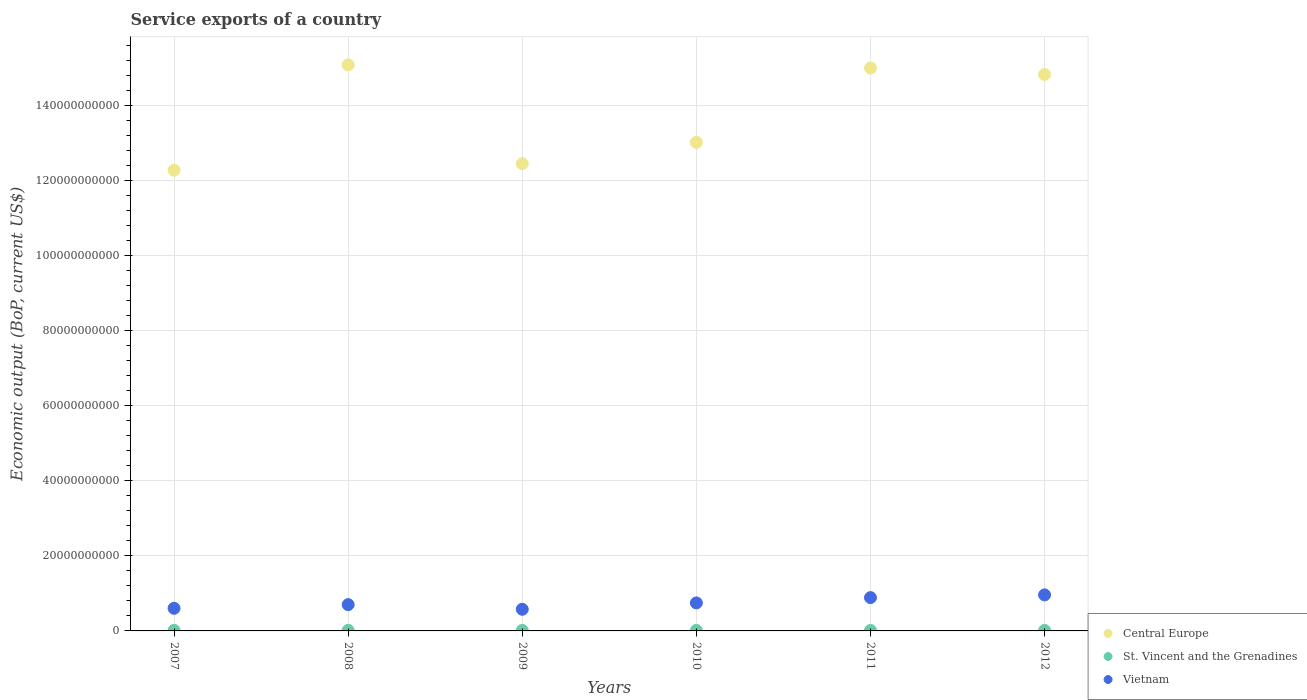How many different coloured dotlines are there?
Make the answer very short. 3. Is the number of dotlines equal to the number of legend labels?
Provide a short and direct response. Yes. What is the service exports in Central Europe in 2009?
Your answer should be compact. 1.25e+11. Across all years, what is the maximum service exports in St. Vincent and the Grenadines?
Make the answer very short. 1.61e+08. Across all years, what is the minimum service exports in Central Europe?
Provide a short and direct response. 1.23e+11. In which year was the service exports in Central Europe maximum?
Give a very brief answer. 2008. What is the total service exports in St. Vincent and the Grenadines in the graph?
Give a very brief answer. 8.71e+08. What is the difference between the service exports in St. Vincent and the Grenadines in 2007 and that in 2010?
Provide a short and direct response. 2.27e+07. What is the difference between the service exports in St. Vincent and the Grenadines in 2011 and the service exports in Vietnam in 2012?
Give a very brief answer. -9.46e+09. What is the average service exports in St. Vincent and the Grenadines per year?
Your answer should be very brief. 1.45e+08. In the year 2009, what is the difference between the service exports in St. Vincent and the Grenadines and service exports in Central Europe?
Your answer should be compact. -1.24e+11. What is the ratio of the service exports in Central Europe in 2008 to that in 2010?
Your answer should be compact. 1.16. Is the difference between the service exports in St. Vincent and the Grenadines in 2008 and 2009 greater than the difference between the service exports in Central Europe in 2008 and 2009?
Give a very brief answer. No. What is the difference between the highest and the second highest service exports in St. Vincent and the Grenadines?
Ensure brevity in your answer.  7.89e+06. What is the difference between the highest and the lowest service exports in Central Europe?
Your response must be concise. 2.81e+1. Is the sum of the service exports in St. Vincent and the Grenadines in 2009 and 2012 greater than the maximum service exports in Vietnam across all years?
Ensure brevity in your answer.  No. Is it the case that in every year, the sum of the service exports in Vietnam and service exports in St. Vincent and the Grenadines  is greater than the service exports in Central Europe?
Offer a very short reply. No. Is the service exports in Central Europe strictly greater than the service exports in Vietnam over the years?
Give a very brief answer. Yes. Are the values on the major ticks of Y-axis written in scientific E-notation?
Give a very brief answer. No. How many legend labels are there?
Ensure brevity in your answer.  3. How are the legend labels stacked?
Your response must be concise. Vertical. What is the title of the graph?
Provide a short and direct response. Service exports of a country. Does "Morocco" appear as one of the legend labels in the graph?
Your response must be concise. No. What is the label or title of the X-axis?
Make the answer very short. Years. What is the label or title of the Y-axis?
Keep it short and to the point. Economic output (BoP, current US$). What is the Economic output (BoP, current US$) in Central Europe in 2007?
Your answer should be compact. 1.23e+11. What is the Economic output (BoP, current US$) of St. Vincent and the Grenadines in 2007?
Your response must be concise. 1.61e+08. What is the Economic output (BoP, current US$) of Vietnam in 2007?
Ensure brevity in your answer.  6.03e+09. What is the Economic output (BoP, current US$) in Central Europe in 2008?
Your answer should be compact. 1.51e+11. What is the Economic output (BoP, current US$) in St. Vincent and the Grenadines in 2008?
Make the answer very short. 1.53e+08. What is the Economic output (BoP, current US$) of Vietnam in 2008?
Offer a terse response. 7.01e+09. What is the Economic output (BoP, current US$) in Central Europe in 2009?
Offer a very short reply. 1.25e+11. What is the Economic output (BoP, current US$) of St. Vincent and the Grenadines in 2009?
Offer a very short reply. 1.39e+08. What is the Economic output (BoP, current US$) in Vietnam in 2009?
Offer a very short reply. 5.77e+09. What is the Economic output (BoP, current US$) in Central Europe in 2010?
Give a very brief answer. 1.30e+11. What is the Economic output (BoP, current US$) of St. Vincent and the Grenadines in 2010?
Provide a succinct answer. 1.38e+08. What is the Economic output (BoP, current US$) in Vietnam in 2010?
Give a very brief answer. 7.46e+09. What is the Economic output (BoP, current US$) in Central Europe in 2011?
Your answer should be compact. 1.50e+11. What is the Economic output (BoP, current US$) in St. Vincent and the Grenadines in 2011?
Provide a succinct answer. 1.39e+08. What is the Economic output (BoP, current US$) of Vietnam in 2011?
Your response must be concise. 8.88e+09. What is the Economic output (BoP, current US$) in Central Europe in 2012?
Keep it short and to the point. 1.48e+11. What is the Economic output (BoP, current US$) in St. Vincent and the Grenadines in 2012?
Make the answer very short. 1.40e+08. What is the Economic output (BoP, current US$) in Vietnam in 2012?
Provide a short and direct response. 9.60e+09. Across all years, what is the maximum Economic output (BoP, current US$) in Central Europe?
Give a very brief answer. 1.51e+11. Across all years, what is the maximum Economic output (BoP, current US$) in St. Vincent and the Grenadines?
Your answer should be very brief. 1.61e+08. Across all years, what is the maximum Economic output (BoP, current US$) in Vietnam?
Ensure brevity in your answer.  9.60e+09. Across all years, what is the minimum Economic output (BoP, current US$) in Central Europe?
Ensure brevity in your answer.  1.23e+11. Across all years, what is the minimum Economic output (BoP, current US$) in St. Vincent and the Grenadines?
Make the answer very short. 1.38e+08. Across all years, what is the minimum Economic output (BoP, current US$) of Vietnam?
Keep it short and to the point. 5.77e+09. What is the total Economic output (BoP, current US$) in Central Europe in the graph?
Give a very brief answer. 8.27e+11. What is the total Economic output (BoP, current US$) in St. Vincent and the Grenadines in the graph?
Make the answer very short. 8.71e+08. What is the total Economic output (BoP, current US$) of Vietnam in the graph?
Provide a short and direct response. 4.47e+1. What is the difference between the Economic output (BoP, current US$) of Central Europe in 2007 and that in 2008?
Your response must be concise. -2.81e+1. What is the difference between the Economic output (BoP, current US$) in St. Vincent and the Grenadines in 2007 and that in 2008?
Give a very brief answer. 7.89e+06. What is the difference between the Economic output (BoP, current US$) in Vietnam in 2007 and that in 2008?
Your response must be concise. -9.76e+08. What is the difference between the Economic output (BoP, current US$) in Central Europe in 2007 and that in 2009?
Ensure brevity in your answer.  -1.76e+09. What is the difference between the Economic output (BoP, current US$) in St. Vincent and the Grenadines in 2007 and that in 2009?
Offer a terse response. 2.19e+07. What is the difference between the Economic output (BoP, current US$) in Vietnam in 2007 and that in 2009?
Ensure brevity in your answer.  2.64e+08. What is the difference between the Economic output (BoP, current US$) in Central Europe in 2007 and that in 2010?
Offer a terse response. -7.44e+09. What is the difference between the Economic output (BoP, current US$) of St. Vincent and the Grenadines in 2007 and that in 2010?
Provide a short and direct response. 2.27e+07. What is the difference between the Economic output (BoP, current US$) of Vietnam in 2007 and that in 2010?
Make the answer very short. -1.43e+09. What is the difference between the Economic output (BoP, current US$) in Central Europe in 2007 and that in 2011?
Your response must be concise. -2.72e+1. What is the difference between the Economic output (BoP, current US$) in St. Vincent and the Grenadines in 2007 and that in 2011?
Give a very brief answer. 2.15e+07. What is the difference between the Economic output (BoP, current US$) in Vietnam in 2007 and that in 2011?
Offer a terse response. -2.85e+09. What is the difference between the Economic output (BoP, current US$) in Central Europe in 2007 and that in 2012?
Offer a terse response. -2.55e+1. What is the difference between the Economic output (BoP, current US$) of St. Vincent and the Grenadines in 2007 and that in 2012?
Make the answer very short. 2.04e+07. What is the difference between the Economic output (BoP, current US$) of Vietnam in 2007 and that in 2012?
Provide a short and direct response. -3.57e+09. What is the difference between the Economic output (BoP, current US$) of Central Europe in 2008 and that in 2009?
Offer a very short reply. 2.63e+1. What is the difference between the Economic output (BoP, current US$) in St. Vincent and the Grenadines in 2008 and that in 2009?
Offer a terse response. 1.40e+07. What is the difference between the Economic output (BoP, current US$) of Vietnam in 2008 and that in 2009?
Provide a succinct answer. 1.24e+09. What is the difference between the Economic output (BoP, current US$) in Central Europe in 2008 and that in 2010?
Offer a very short reply. 2.06e+1. What is the difference between the Economic output (BoP, current US$) in St. Vincent and the Grenadines in 2008 and that in 2010?
Your answer should be compact. 1.48e+07. What is the difference between the Economic output (BoP, current US$) in Vietnam in 2008 and that in 2010?
Offer a very short reply. -4.54e+08. What is the difference between the Economic output (BoP, current US$) in Central Europe in 2008 and that in 2011?
Provide a short and direct response. 8.36e+08. What is the difference between the Economic output (BoP, current US$) in St. Vincent and the Grenadines in 2008 and that in 2011?
Offer a very short reply. 1.36e+07. What is the difference between the Economic output (BoP, current US$) of Vietnam in 2008 and that in 2011?
Give a very brief answer. -1.87e+09. What is the difference between the Economic output (BoP, current US$) in Central Europe in 2008 and that in 2012?
Your answer should be very brief. 2.55e+09. What is the difference between the Economic output (BoP, current US$) of St. Vincent and the Grenadines in 2008 and that in 2012?
Your answer should be compact. 1.25e+07. What is the difference between the Economic output (BoP, current US$) of Vietnam in 2008 and that in 2012?
Keep it short and to the point. -2.59e+09. What is the difference between the Economic output (BoP, current US$) of Central Europe in 2009 and that in 2010?
Keep it short and to the point. -5.67e+09. What is the difference between the Economic output (BoP, current US$) of St. Vincent and the Grenadines in 2009 and that in 2010?
Provide a succinct answer. 7.68e+05. What is the difference between the Economic output (BoP, current US$) in Vietnam in 2009 and that in 2010?
Make the answer very short. -1.69e+09. What is the difference between the Economic output (BoP, current US$) in Central Europe in 2009 and that in 2011?
Your answer should be very brief. -2.55e+1. What is the difference between the Economic output (BoP, current US$) in St. Vincent and the Grenadines in 2009 and that in 2011?
Make the answer very short. -4.17e+05. What is the difference between the Economic output (BoP, current US$) of Vietnam in 2009 and that in 2011?
Make the answer very short. -3.11e+09. What is the difference between the Economic output (BoP, current US$) in Central Europe in 2009 and that in 2012?
Your response must be concise. -2.38e+1. What is the difference between the Economic output (BoP, current US$) in St. Vincent and the Grenadines in 2009 and that in 2012?
Offer a terse response. -1.53e+06. What is the difference between the Economic output (BoP, current US$) of Vietnam in 2009 and that in 2012?
Keep it short and to the point. -3.83e+09. What is the difference between the Economic output (BoP, current US$) in Central Europe in 2010 and that in 2011?
Provide a succinct answer. -1.98e+1. What is the difference between the Economic output (BoP, current US$) of St. Vincent and the Grenadines in 2010 and that in 2011?
Provide a short and direct response. -1.19e+06. What is the difference between the Economic output (BoP, current US$) of Vietnam in 2010 and that in 2011?
Provide a succinct answer. -1.42e+09. What is the difference between the Economic output (BoP, current US$) of Central Europe in 2010 and that in 2012?
Your answer should be compact. -1.81e+1. What is the difference between the Economic output (BoP, current US$) of St. Vincent and the Grenadines in 2010 and that in 2012?
Provide a short and direct response. -2.30e+06. What is the difference between the Economic output (BoP, current US$) in Vietnam in 2010 and that in 2012?
Offer a very short reply. -2.14e+09. What is the difference between the Economic output (BoP, current US$) in Central Europe in 2011 and that in 2012?
Provide a succinct answer. 1.72e+09. What is the difference between the Economic output (BoP, current US$) of St. Vincent and the Grenadines in 2011 and that in 2012?
Your answer should be compact. -1.12e+06. What is the difference between the Economic output (BoP, current US$) in Vietnam in 2011 and that in 2012?
Ensure brevity in your answer.  -7.21e+08. What is the difference between the Economic output (BoP, current US$) in Central Europe in 2007 and the Economic output (BoP, current US$) in St. Vincent and the Grenadines in 2008?
Offer a very short reply. 1.23e+11. What is the difference between the Economic output (BoP, current US$) of Central Europe in 2007 and the Economic output (BoP, current US$) of Vietnam in 2008?
Make the answer very short. 1.16e+11. What is the difference between the Economic output (BoP, current US$) of St. Vincent and the Grenadines in 2007 and the Economic output (BoP, current US$) of Vietnam in 2008?
Offer a very short reply. -6.85e+09. What is the difference between the Economic output (BoP, current US$) in Central Europe in 2007 and the Economic output (BoP, current US$) in St. Vincent and the Grenadines in 2009?
Ensure brevity in your answer.  1.23e+11. What is the difference between the Economic output (BoP, current US$) of Central Europe in 2007 and the Economic output (BoP, current US$) of Vietnam in 2009?
Keep it short and to the point. 1.17e+11. What is the difference between the Economic output (BoP, current US$) in St. Vincent and the Grenadines in 2007 and the Economic output (BoP, current US$) in Vietnam in 2009?
Your response must be concise. -5.61e+09. What is the difference between the Economic output (BoP, current US$) in Central Europe in 2007 and the Economic output (BoP, current US$) in St. Vincent and the Grenadines in 2010?
Provide a short and direct response. 1.23e+11. What is the difference between the Economic output (BoP, current US$) of Central Europe in 2007 and the Economic output (BoP, current US$) of Vietnam in 2010?
Give a very brief answer. 1.15e+11. What is the difference between the Economic output (BoP, current US$) of St. Vincent and the Grenadines in 2007 and the Economic output (BoP, current US$) of Vietnam in 2010?
Offer a very short reply. -7.30e+09. What is the difference between the Economic output (BoP, current US$) of Central Europe in 2007 and the Economic output (BoP, current US$) of St. Vincent and the Grenadines in 2011?
Give a very brief answer. 1.23e+11. What is the difference between the Economic output (BoP, current US$) of Central Europe in 2007 and the Economic output (BoP, current US$) of Vietnam in 2011?
Provide a succinct answer. 1.14e+11. What is the difference between the Economic output (BoP, current US$) of St. Vincent and the Grenadines in 2007 and the Economic output (BoP, current US$) of Vietnam in 2011?
Your response must be concise. -8.72e+09. What is the difference between the Economic output (BoP, current US$) in Central Europe in 2007 and the Economic output (BoP, current US$) in St. Vincent and the Grenadines in 2012?
Give a very brief answer. 1.23e+11. What is the difference between the Economic output (BoP, current US$) of Central Europe in 2007 and the Economic output (BoP, current US$) of Vietnam in 2012?
Ensure brevity in your answer.  1.13e+11. What is the difference between the Economic output (BoP, current US$) of St. Vincent and the Grenadines in 2007 and the Economic output (BoP, current US$) of Vietnam in 2012?
Your answer should be compact. -9.44e+09. What is the difference between the Economic output (BoP, current US$) in Central Europe in 2008 and the Economic output (BoP, current US$) in St. Vincent and the Grenadines in 2009?
Offer a terse response. 1.51e+11. What is the difference between the Economic output (BoP, current US$) of Central Europe in 2008 and the Economic output (BoP, current US$) of Vietnam in 2009?
Offer a very short reply. 1.45e+11. What is the difference between the Economic output (BoP, current US$) in St. Vincent and the Grenadines in 2008 and the Economic output (BoP, current US$) in Vietnam in 2009?
Give a very brief answer. -5.61e+09. What is the difference between the Economic output (BoP, current US$) of Central Europe in 2008 and the Economic output (BoP, current US$) of St. Vincent and the Grenadines in 2010?
Ensure brevity in your answer.  1.51e+11. What is the difference between the Economic output (BoP, current US$) of Central Europe in 2008 and the Economic output (BoP, current US$) of Vietnam in 2010?
Your answer should be very brief. 1.43e+11. What is the difference between the Economic output (BoP, current US$) of St. Vincent and the Grenadines in 2008 and the Economic output (BoP, current US$) of Vietnam in 2010?
Give a very brief answer. -7.31e+09. What is the difference between the Economic output (BoP, current US$) of Central Europe in 2008 and the Economic output (BoP, current US$) of St. Vincent and the Grenadines in 2011?
Provide a succinct answer. 1.51e+11. What is the difference between the Economic output (BoP, current US$) in Central Europe in 2008 and the Economic output (BoP, current US$) in Vietnam in 2011?
Provide a short and direct response. 1.42e+11. What is the difference between the Economic output (BoP, current US$) of St. Vincent and the Grenadines in 2008 and the Economic output (BoP, current US$) of Vietnam in 2011?
Your answer should be compact. -8.73e+09. What is the difference between the Economic output (BoP, current US$) in Central Europe in 2008 and the Economic output (BoP, current US$) in St. Vincent and the Grenadines in 2012?
Offer a very short reply. 1.51e+11. What is the difference between the Economic output (BoP, current US$) of Central Europe in 2008 and the Economic output (BoP, current US$) of Vietnam in 2012?
Make the answer very short. 1.41e+11. What is the difference between the Economic output (BoP, current US$) of St. Vincent and the Grenadines in 2008 and the Economic output (BoP, current US$) of Vietnam in 2012?
Provide a succinct answer. -9.45e+09. What is the difference between the Economic output (BoP, current US$) of Central Europe in 2009 and the Economic output (BoP, current US$) of St. Vincent and the Grenadines in 2010?
Give a very brief answer. 1.24e+11. What is the difference between the Economic output (BoP, current US$) of Central Europe in 2009 and the Economic output (BoP, current US$) of Vietnam in 2010?
Provide a short and direct response. 1.17e+11. What is the difference between the Economic output (BoP, current US$) of St. Vincent and the Grenadines in 2009 and the Economic output (BoP, current US$) of Vietnam in 2010?
Ensure brevity in your answer.  -7.32e+09. What is the difference between the Economic output (BoP, current US$) in Central Europe in 2009 and the Economic output (BoP, current US$) in St. Vincent and the Grenadines in 2011?
Provide a short and direct response. 1.24e+11. What is the difference between the Economic output (BoP, current US$) in Central Europe in 2009 and the Economic output (BoP, current US$) in Vietnam in 2011?
Your answer should be compact. 1.16e+11. What is the difference between the Economic output (BoP, current US$) in St. Vincent and the Grenadines in 2009 and the Economic output (BoP, current US$) in Vietnam in 2011?
Make the answer very short. -8.74e+09. What is the difference between the Economic output (BoP, current US$) of Central Europe in 2009 and the Economic output (BoP, current US$) of St. Vincent and the Grenadines in 2012?
Give a very brief answer. 1.24e+11. What is the difference between the Economic output (BoP, current US$) in Central Europe in 2009 and the Economic output (BoP, current US$) in Vietnam in 2012?
Offer a terse response. 1.15e+11. What is the difference between the Economic output (BoP, current US$) of St. Vincent and the Grenadines in 2009 and the Economic output (BoP, current US$) of Vietnam in 2012?
Offer a very short reply. -9.46e+09. What is the difference between the Economic output (BoP, current US$) in Central Europe in 2010 and the Economic output (BoP, current US$) in St. Vincent and the Grenadines in 2011?
Provide a succinct answer. 1.30e+11. What is the difference between the Economic output (BoP, current US$) of Central Europe in 2010 and the Economic output (BoP, current US$) of Vietnam in 2011?
Provide a short and direct response. 1.21e+11. What is the difference between the Economic output (BoP, current US$) in St. Vincent and the Grenadines in 2010 and the Economic output (BoP, current US$) in Vietnam in 2011?
Your response must be concise. -8.74e+09. What is the difference between the Economic output (BoP, current US$) in Central Europe in 2010 and the Economic output (BoP, current US$) in St. Vincent and the Grenadines in 2012?
Make the answer very short. 1.30e+11. What is the difference between the Economic output (BoP, current US$) of Central Europe in 2010 and the Economic output (BoP, current US$) of Vietnam in 2012?
Your answer should be compact. 1.21e+11. What is the difference between the Economic output (BoP, current US$) of St. Vincent and the Grenadines in 2010 and the Economic output (BoP, current US$) of Vietnam in 2012?
Offer a terse response. -9.46e+09. What is the difference between the Economic output (BoP, current US$) in Central Europe in 2011 and the Economic output (BoP, current US$) in St. Vincent and the Grenadines in 2012?
Ensure brevity in your answer.  1.50e+11. What is the difference between the Economic output (BoP, current US$) in Central Europe in 2011 and the Economic output (BoP, current US$) in Vietnam in 2012?
Your response must be concise. 1.40e+11. What is the difference between the Economic output (BoP, current US$) in St. Vincent and the Grenadines in 2011 and the Economic output (BoP, current US$) in Vietnam in 2012?
Your answer should be compact. -9.46e+09. What is the average Economic output (BoP, current US$) of Central Europe per year?
Your answer should be very brief. 1.38e+11. What is the average Economic output (BoP, current US$) of St. Vincent and the Grenadines per year?
Your answer should be very brief. 1.45e+08. What is the average Economic output (BoP, current US$) of Vietnam per year?
Give a very brief answer. 7.46e+09. In the year 2007, what is the difference between the Economic output (BoP, current US$) of Central Europe and Economic output (BoP, current US$) of St. Vincent and the Grenadines?
Provide a succinct answer. 1.23e+11. In the year 2007, what is the difference between the Economic output (BoP, current US$) of Central Europe and Economic output (BoP, current US$) of Vietnam?
Your answer should be very brief. 1.17e+11. In the year 2007, what is the difference between the Economic output (BoP, current US$) in St. Vincent and the Grenadines and Economic output (BoP, current US$) in Vietnam?
Offer a very short reply. -5.87e+09. In the year 2008, what is the difference between the Economic output (BoP, current US$) of Central Europe and Economic output (BoP, current US$) of St. Vincent and the Grenadines?
Offer a terse response. 1.51e+11. In the year 2008, what is the difference between the Economic output (BoP, current US$) in Central Europe and Economic output (BoP, current US$) in Vietnam?
Ensure brevity in your answer.  1.44e+11. In the year 2008, what is the difference between the Economic output (BoP, current US$) in St. Vincent and the Grenadines and Economic output (BoP, current US$) in Vietnam?
Your answer should be compact. -6.85e+09. In the year 2009, what is the difference between the Economic output (BoP, current US$) in Central Europe and Economic output (BoP, current US$) in St. Vincent and the Grenadines?
Give a very brief answer. 1.24e+11. In the year 2009, what is the difference between the Economic output (BoP, current US$) of Central Europe and Economic output (BoP, current US$) of Vietnam?
Give a very brief answer. 1.19e+11. In the year 2009, what is the difference between the Economic output (BoP, current US$) in St. Vincent and the Grenadines and Economic output (BoP, current US$) in Vietnam?
Offer a terse response. -5.63e+09. In the year 2010, what is the difference between the Economic output (BoP, current US$) in Central Europe and Economic output (BoP, current US$) in St. Vincent and the Grenadines?
Your answer should be compact. 1.30e+11. In the year 2010, what is the difference between the Economic output (BoP, current US$) in Central Europe and Economic output (BoP, current US$) in Vietnam?
Offer a very short reply. 1.23e+11. In the year 2010, what is the difference between the Economic output (BoP, current US$) in St. Vincent and the Grenadines and Economic output (BoP, current US$) in Vietnam?
Provide a succinct answer. -7.32e+09. In the year 2011, what is the difference between the Economic output (BoP, current US$) of Central Europe and Economic output (BoP, current US$) of St. Vincent and the Grenadines?
Give a very brief answer. 1.50e+11. In the year 2011, what is the difference between the Economic output (BoP, current US$) of Central Europe and Economic output (BoP, current US$) of Vietnam?
Your response must be concise. 1.41e+11. In the year 2011, what is the difference between the Economic output (BoP, current US$) of St. Vincent and the Grenadines and Economic output (BoP, current US$) of Vietnam?
Offer a very short reply. -8.74e+09. In the year 2012, what is the difference between the Economic output (BoP, current US$) in Central Europe and Economic output (BoP, current US$) in St. Vincent and the Grenadines?
Ensure brevity in your answer.  1.48e+11. In the year 2012, what is the difference between the Economic output (BoP, current US$) of Central Europe and Economic output (BoP, current US$) of Vietnam?
Your response must be concise. 1.39e+11. In the year 2012, what is the difference between the Economic output (BoP, current US$) in St. Vincent and the Grenadines and Economic output (BoP, current US$) in Vietnam?
Your response must be concise. -9.46e+09. What is the ratio of the Economic output (BoP, current US$) of Central Europe in 2007 to that in 2008?
Offer a very short reply. 0.81. What is the ratio of the Economic output (BoP, current US$) in St. Vincent and the Grenadines in 2007 to that in 2008?
Keep it short and to the point. 1.05. What is the ratio of the Economic output (BoP, current US$) in Vietnam in 2007 to that in 2008?
Keep it short and to the point. 0.86. What is the ratio of the Economic output (BoP, current US$) in Central Europe in 2007 to that in 2009?
Give a very brief answer. 0.99. What is the ratio of the Economic output (BoP, current US$) in St. Vincent and the Grenadines in 2007 to that in 2009?
Provide a short and direct response. 1.16. What is the ratio of the Economic output (BoP, current US$) of Vietnam in 2007 to that in 2009?
Your answer should be compact. 1.05. What is the ratio of the Economic output (BoP, current US$) of Central Europe in 2007 to that in 2010?
Provide a succinct answer. 0.94. What is the ratio of the Economic output (BoP, current US$) of St. Vincent and the Grenadines in 2007 to that in 2010?
Your answer should be compact. 1.16. What is the ratio of the Economic output (BoP, current US$) of Vietnam in 2007 to that in 2010?
Offer a terse response. 0.81. What is the ratio of the Economic output (BoP, current US$) in Central Europe in 2007 to that in 2011?
Provide a succinct answer. 0.82. What is the ratio of the Economic output (BoP, current US$) of St. Vincent and the Grenadines in 2007 to that in 2011?
Ensure brevity in your answer.  1.15. What is the ratio of the Economic output (BoP, current US$) of Vietnam in 2007 to that in 2011?
Make the answer very short. 0.68. What is the ratio of the Economic output (BoP, current US$) in Central Europe in 2007 to that in 2012?
Keep it short and to the point. 0.83. What is the ratio of the Economic output (BoP, current US$) in St. Vincent and the Grenadines in 2007 to that in 2012?
Your answer should be compact. 1.15. What is the ratio of the Economic output (BoP, current US$) in Vietnam in 2007 to that in 2012?
Offer a terse response. 0.63. What is the ratio of the Economic output (BoP, current US$) in Central Europe in 2008 to that in 2009?
Your answer should be compact. 1.21. What is the ratio of the Economic output (BoP, current US$) in St. Vincent and the Grenadines in 2008 to that in 2009?
Your response must be concise. 1.1. What is the ratio of the Economic output (BoP, current US$) in Vietnam in 2008 to that in 2009?
Offer a very short reply. 1.22. What is the ratio of the Economic output (BoP, current US$) in Central Europe in 2008 to that in 2010?
Ensure brevity in your answer.  1.16. What is the ratio of the Economic output (BoP, current US$) in St. Vincent and the Grenadines in 2008 to that in 2010?
Offer a very short reply. 1.11. What is the ratio of the Economic output (BoP, current US$) in Vietnam in 2008 to that in 2010?
Your answer should be compact. 0.94. What is the ratio of the Economic output (BoP, current US$) in Central Europe in 2008 to that in 2011?
Ensure brevity in your answer.  1.01. What is the ratio of the Economic output (BoP, current US$) in St. Vincent and the Grenadines in 2008 to that in 2011?
Offer a terse response. 1.1. What is the ratio of the Economic output (BoP, current US$) in Vietnam in 2008 to that in 2011?
Keep it short and to the point. 0.79. What is the ratio of the Economic output (BoP, current US$) in Central Europe in 2008 to that in 2012?
Give a very brief answer. 1.02. What is the ratio of the Economic output (BoP, current US$) of St. Vincent and the Grenadines in 2008 to that in 2012?
Your answer should be very brief. 1.09. What is the ratio of the Economic output (BoP, current US$) of Vietnam in 2008 to that in 2012?
Your answer should be very brief. 0.73. What is the ratio of the Economic output (BoP, current US$) of Central Europe in 2009 to that in 2010?
Ensure brevity in your answer.  0.96. What is the ratio of the Economic output (BoP, current US$) in St. Vincent and the Grenadines in 2009 to that in 2010?
Provide a short and direct response. 1.01. What is the ratio of the Economic output (BoP, current US$) in Vietnam in 2009 to that in 2010?
Your answer should be compact. 0.77. What is the ratio of the Economic output (BoP, current US$) in Central Europe in 2009 to that in 2011?
Ensure brevity in your answer.  0.83. What is the ratio of the Economic output (BoP, current US$) in St. Vincent and the Grenadines in 2009 to that in 2011?
Provide a short and direct response. 1. What is the ratio of the Economic output (BoP, current US$) of Vietnam in 2009 to that in 2011?
Your response must be concise. 0.65. What is the ratio of the Economic output (BoP, current US$) of Central Europe in 2009 to that in 2012?
Make the answer very short. 0.84. What is the ratio of the Economic output (BoP, current US$) of St. Vincent and the Grenadines in 2009 to that in 2012?
Your answer should be compact. 0.99. What is the ratio of the Economic output (BoP, current US$) of Vietnam in 2009 to that in 2012?
Offer a terse response. 0.6. What is the ratio of the Economic output (BoP, current US$) in Central Europe in 2010 to that in 2011?
Give a very brief answer. 0.87. What is the ratio of the Economic output (BoP, current US$) of St. Vincent and the Grenadines in 2010 to that in 2011?
Offer a very short reply. 0.99. What is the ratio of the Economic output (BoP, current US$) in Vietnam in 2010 to that in 2011?
Give a very brief answer. 0.84. What is the ratio of the Economic output (BoP, current US$) of Central Europe in 2010 to that in 2012?
Make the answer very short. 0.88. What is the ratio of the Economic output (BoP, current US$) in St. Vincent and the Grenadines in 2010 to that in 2012?
Make the answer very short. 0.98. What is the ratio of the Economic output (BoP, current US$) of Vietnam in 2010 to that in 2012?
Make the answer very short. 0.78. What is the ratio of the Economic output (BoP, current US$) of Central Europe in 2011 to that in 2012?
Offer a terse response. 1.01. What is the ratio of the Economic output (BoP, current US$) of St. Vincent and the Grenadines in 2011 to that in 2012?
Your response must be concise. 0.99. What is the ratio of the Economic output (BoP, current US$) of Vietnam in 2011 to that in 2012?
Keep it short and to the point. 0.92. What is the difference between the highest and the second highest Economic output (BoP, current US$) of Central Europe?
Offer a very short reply. 8.36e+08. What is the difference between the highest and the second highest Economic output (BoP, current US$) in St. Vincent and the Grenadines?
Offer a terse response. 7.89e+06. What is the difference between the highest and the second highest Economic output (BoP, current US$) in Vietnam?
Your answer should be very brief. 7.21e+08. What is the difference between the highest and the lowest Economic output (BoP, current US$) in Central Europe?
Provide a short and direct response. 2.81e+1. What is the difference between the highest and the lowest Economic output (BoP, current US$) in St. Vincent and the Grenadines?
Keep it short and to the point. 2.27e+07. What is the difference between the highest and the lowest Economic output (BoP, current US$) of Vietnam?
Make the answer very short. 3.83e+09. 